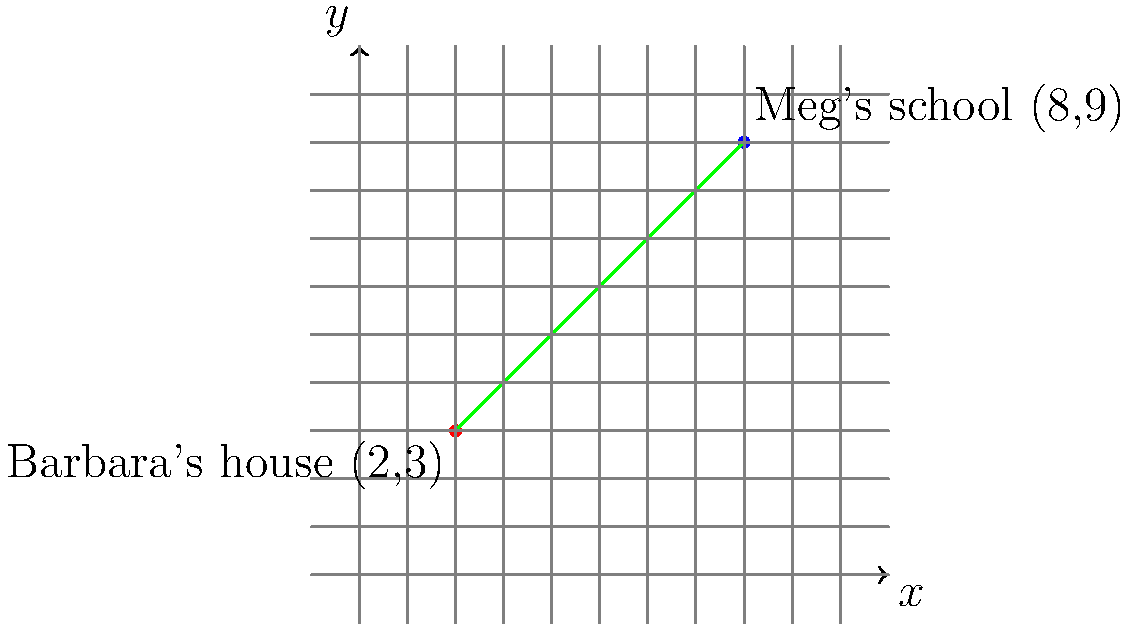As Meg's best friend, you're helping her with a math problem. On a coordinate plane, Barbara's house is located at (2,3) and Meg's school is at (8,9). Calculate the slope of the line connecting these two points. To calculate the slope of a line connecting two points, we use the slope formula:

$$ \text{slope} = m = \frac{y_2 - y_1}{x_2 - x_1} $$

Where $(x_1, y_1)$ is the first point and $(x_2, y_2)$ is the second point.

In this case:
- Barbara's house: $(x_1, y_1) = (2, 3)$
- Meg's school: $(x_2, y_2) = (8, 9)$

Let's plug these values into the formula:

$$ m = \frac{9 - 3}{8 - 2} = \frac{6}{6} $$

Simplifying the fraction:

$$ m = 1 $$

Therefore, the slope of the line connecting Barbara's house and Meg's school is 1.
Answer: $1$ 